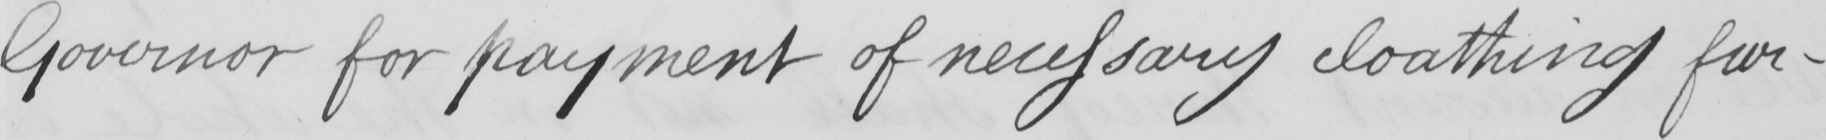Can you read and transcribe this handwriting? Governor for payment of necessary cloathing fur- 